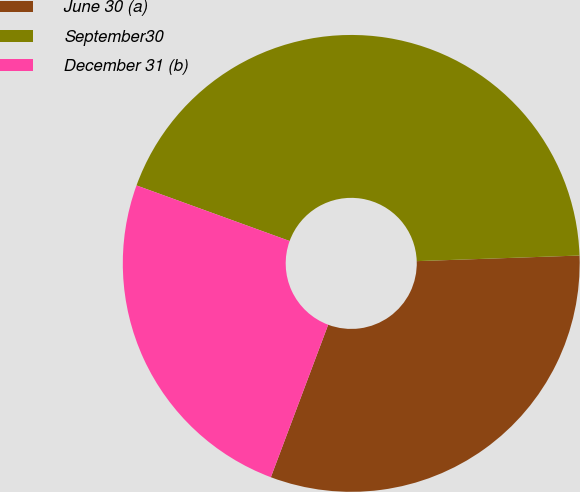Convert chart. <chart><loc_0><loc_0><loc_500><loc_500><pie_chart><fcel>June 30 (a)<fcel>September30<fcel>December 31 (b)<nl><fcel>31.27%<fcel>43.91%<fcel>24.82%<nl></chart> 